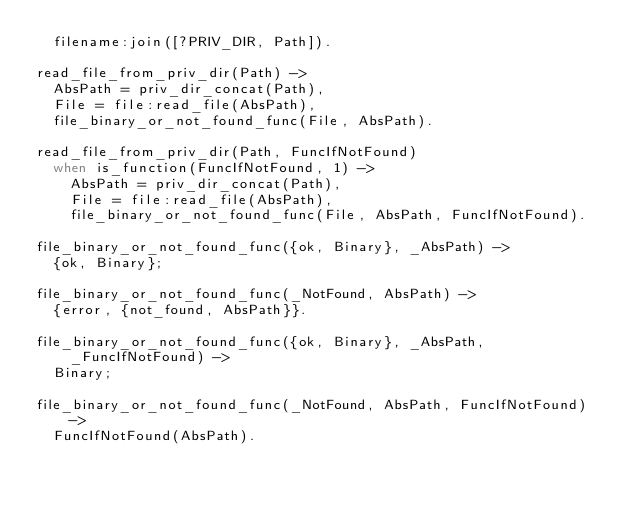Convert code to text. <code><loc_0><loc_0><loc_500><loc_500><_Erlang_>  filename:join([?PRIV_DIR, Path]).

read_file_from_priv_dir(Path) ->
  AbsPath = priv_dir_concat(Path),
  File = file:read_file(AbsPath),
  file_binary_or_not_found_func(File, AbsPath).

read_file_from_priv_dir(Path, FuncIfNotFound)
  when is_function(FuncIfNotFound, 1) ->
    AbsPath = priv_dir_concat(Path),
    File = file:read_file(AbsPath),
    file_binary_or_not_found_func(File, AbsPath, FuncIfNotFound).

file_binary_or_not_found_func({ok, Binary}, _AbsPath) ->
  {ok, Binary};

file_binary_or_not_found_func(_NotFound, AbsPath) ->
  {error, {not_found, AbsPath}}.

file_binary_or_not_found_func({ok, Binary}, _AbsPath, _FuncIfNotFound) ->
  Binary;

file_binary_or_not_found_func(_NotFound, AbsPath, FuncIfNotFound) ->
  FuncIfNotFound(AbsPath).
</code> 